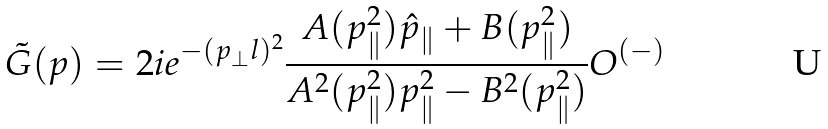Convert formula to latex. <formula><loc_0><loc_0><loc_500><loc_500>\tilde { G } ( p ) = 2 i e ^ { - ( p _ { \perp } l ) ^ { 2 } } \frac { A ( p _ { \| } ^ { 2 } ) \hat { p } _ { \| } + B ( p _ { \| } ^ { 2 } ) } { A ^ { 2 } ( p _ { \| } ^ { 2 } ) p ^ { 2 } _ { \| } - B ^ { 2 } ( p _ { \| } ^ { 2 } ) } O ^ { ( - ) }</formula> 